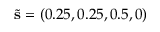<formula> <loc_0><loc_0><loc_500><loc_500>\tilde { s } = ( 0 . 2 5 , 0 . 2 5 , 0 . 5 , 0 )</formula> 